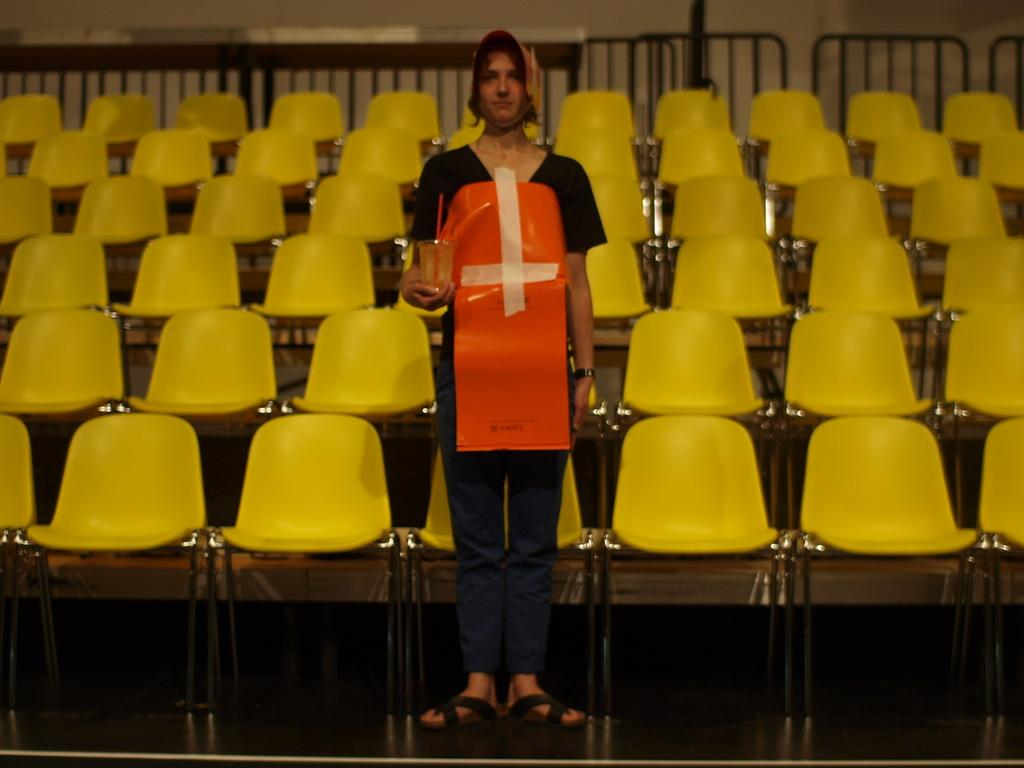What is the main subject of the image? There is a person standing in the middle of the image. What is the person holding in the image? The person is holding a glass. What can be seen behind the person? There are chairs behind the person. What is located behind the chairs? There is fencing behind the chairs. What is the background of the image? There is a wall behind the fencing. What type of vein is visible on the person's hand in the image? There is no visible vein on the person's hand in the image. Can you see a crow perched on the wall in the background of the image? There is no crow present in the image. 